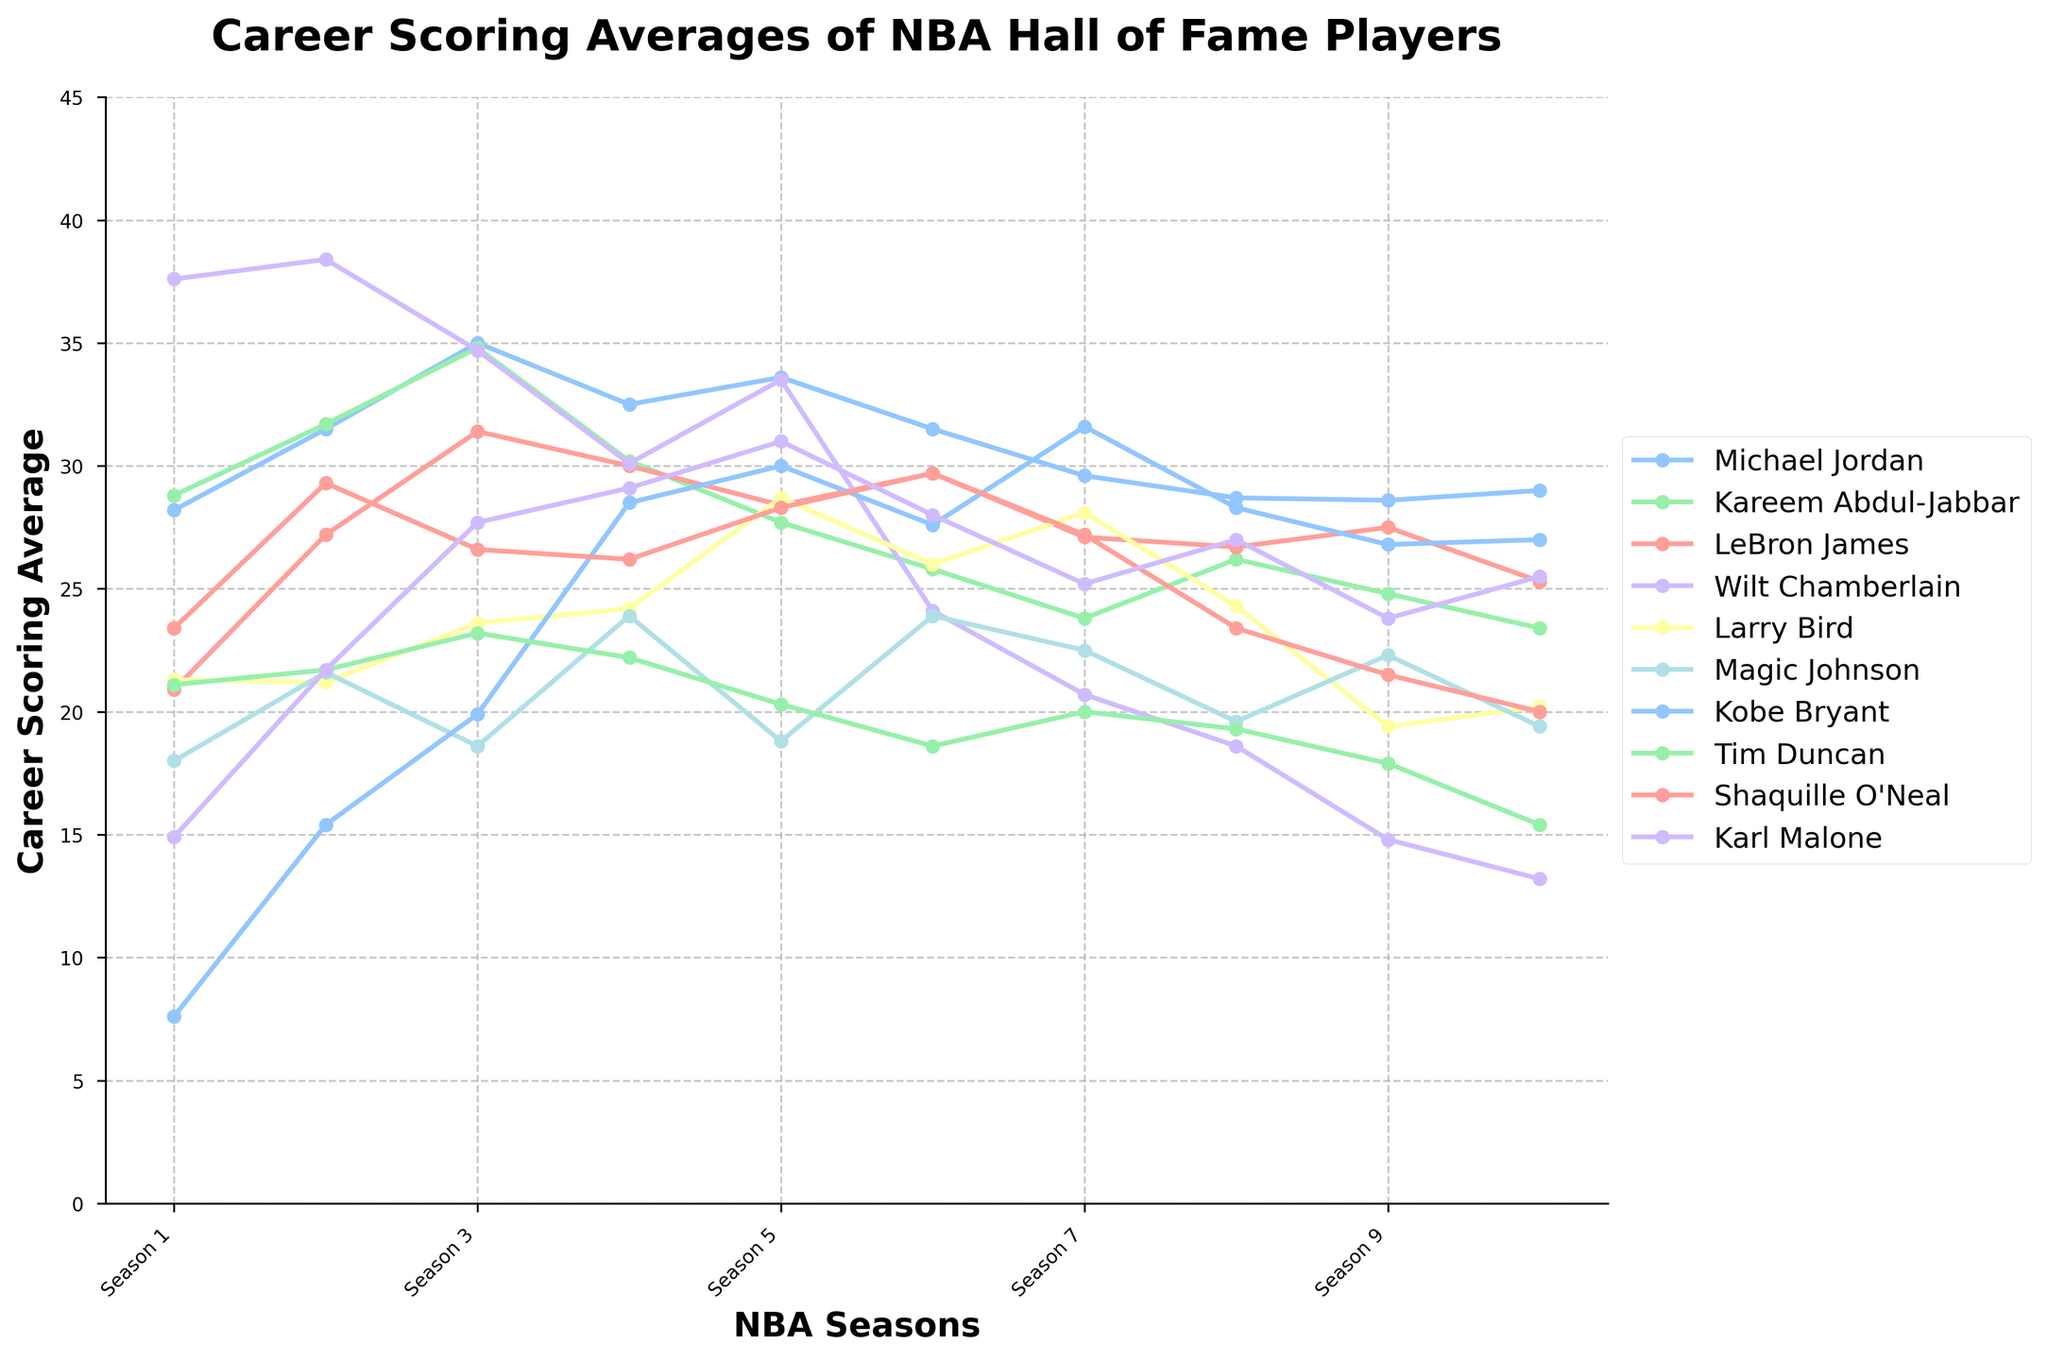Which player had the highest scoring average in any single season? To find the highest scoring average, review each player's scoring averages across all seasons. Identify the maximum value. Wilt Chamberlain has the highest single-season scoring average of 38.4 in Season 2.
Answer: Wilt Chamberlain Who had the lowest scoring average in their first season? Compare the first season's scoring averages of all players and pick the smallest value. Kobe Bryant had the lowest scoring average in his first season with 7.6 points.
Answer: Kobe Bryant Between Michael Jordan and Kareem Abdul-Jabbar, who maintained a higher scoring average in the fourth season? Look at the scoring averages of both players in the fourth season and compare. Michael Jordan averaged 32.5, while Kareem Abdul-Jabbar averaged 30.2 in their fourth season.
Answer: Michael Jordan Which player showed the most consistent scoring average across the ten seasons? Consistency can be interpreted as having the least variability. Calculate the standard deviation of scoring averages for each player and find the player with the lowest. Larry Bird's standard deviation is lowest, indicating most consistency.
Answer: Larry Bird What is the average scoring average of LeBron James over the ten seasons? Sum up LeBron James’ scores across all ten seasons, then divide by ten. LeBron James' scores sum to 274.2, so the average is 274.2/10 = 27.42.
Answer: 27.42 Which player's scoring average showed the most significant drop between the first and last seasons? Calculate the difference between the first and last seasons for each player. Wilt Chamberlain's difference (37.6 - 13.2 = 24.4) is the largest drop.
Answer: Wilt Chamberlain How many players had a scoring average of over 30 points in any season? Count the number of players who had a scoring average exceeding 30 in any single season. The players meeting this criterion are Michael Jordan, Kareem Abdul-Jabbar, LeBron James, Wilt Chamberlain, Kobe Bryant, and Karl Malone - a total of 6 players.
Answer: 6 In which season did Shaquille O'Neal have his highest scoring average? Review Shaquille O'Neal’s scoring averages for all seasons and identify the maximum value. Shaquille O'Neal had his highest average in Season 6 with 29.7 points.
Answer: Season 6 Which player had the greatest increase in their scoring average from one season to the next? Compute the differences between consecutive seasons for each player and identify the maximum increase. Karl Malone had the greatest increase from Season 1 to Season 2 (21.7 - 14.9 = 6.8).
Answer: Karl Malone Is there any player whose scoring average never dropped below 20 points in any season? Check all ten seasons for each player to see if their scoring average stays above 20 points. Kareem Abdul-Jabbar and Michael Jordan's averages never dropped below 20 points.
Answer: Kareem Abdul-Jabbar, Michael Jordan 